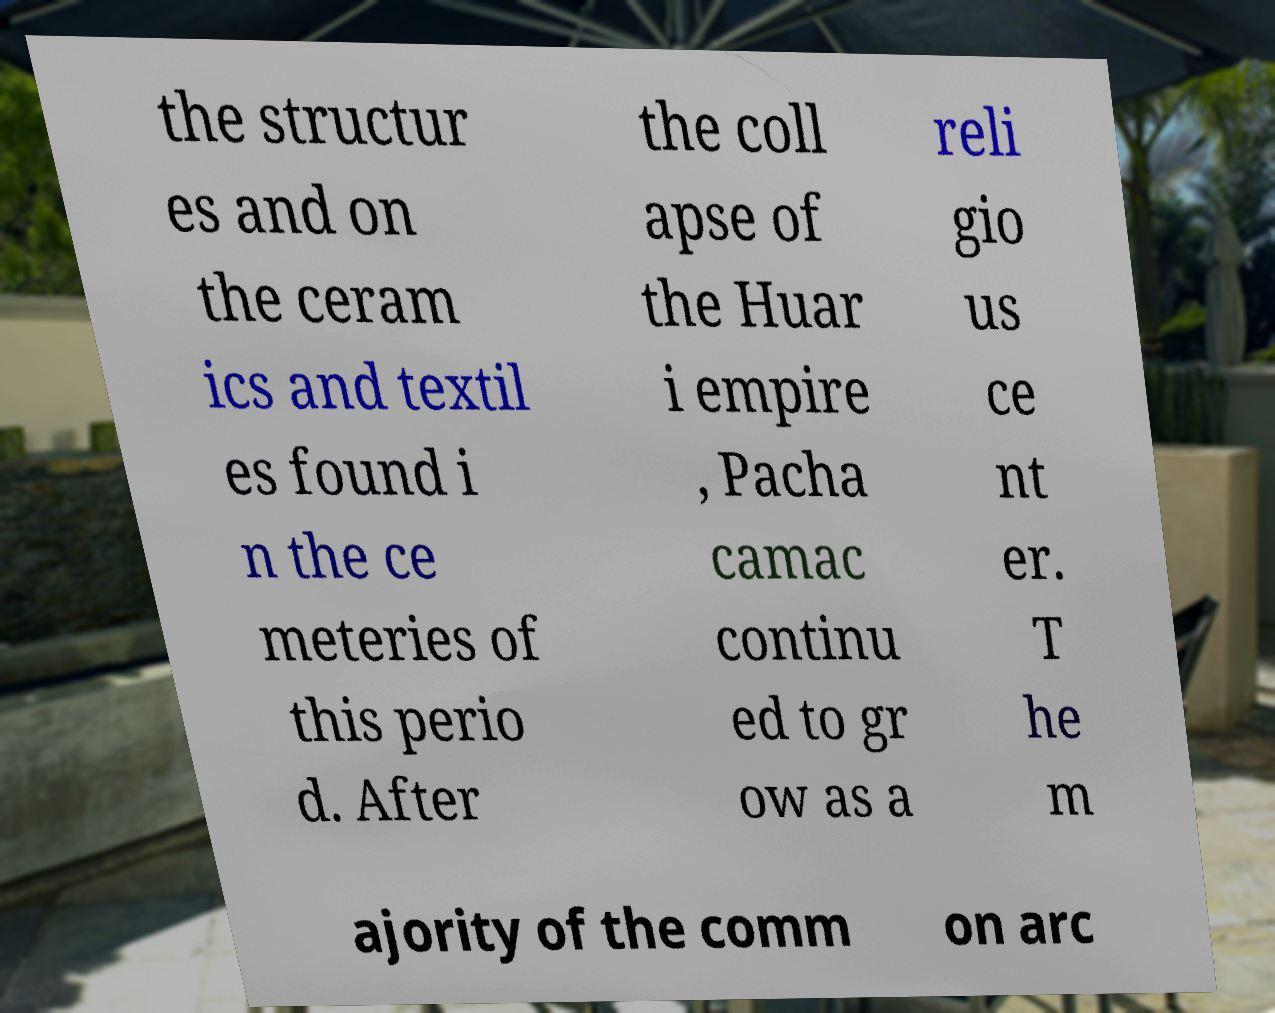For documentation purposes, I need the text within this image transcribed. Could you provide that? the structur es and on the ceram ics and textil es found i n the ce meteries of this perio d. After the coll apse of the Huar i empire , Pacha camac continu ed to gr ow as a reli gio us ce nt er. T he m ajority of the comm on arc 